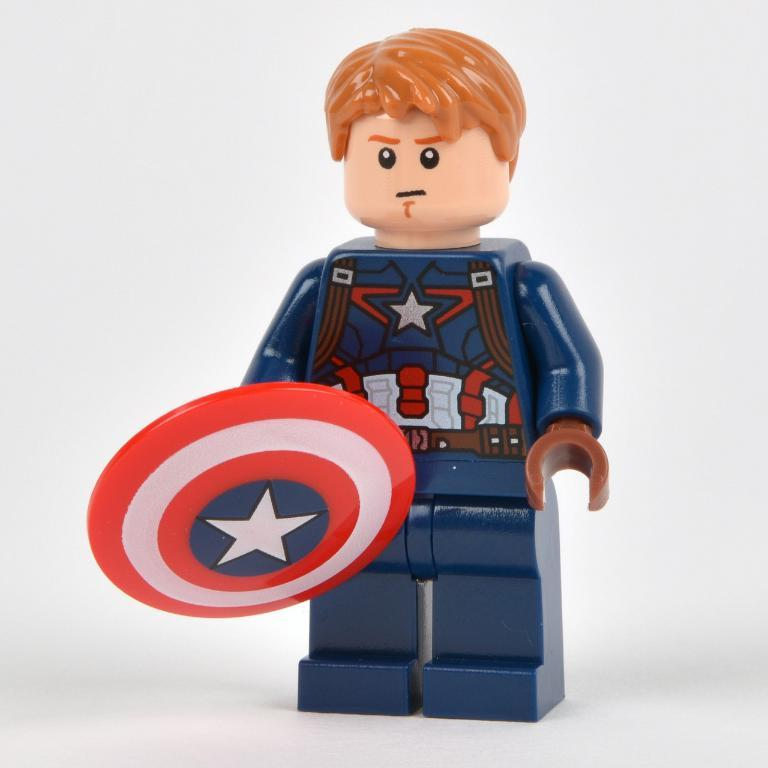What color is the toy in the picture? The toy in the picture is blue. What is the toy holding in its hand? The toy is holding a shield in its hand. What type of clouds can be seen in the picture? There are no clouds visible in the picture, as it only features a blue toy holding a shield. Is there a person holding the crayon in the picture? There is no person or crayon present in the picture; it only features a blue toy holding a shield. 